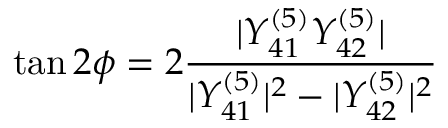<formula> <loc_0><loc_0><loc_500><loc_500>\tan { 2 \phi } = 2 \frac { | Y _ { 4 1 } ^ { ( 5 ) } Y _ { 4 2 } ^ { ( 5 ) } | } { | Y _ { 4 1 } ^ { ( 5 ) } | ^ { 2 } - | Y _ { 4 2 } ^ { ( 5 ) } | ^ { 2 } }</formula> 